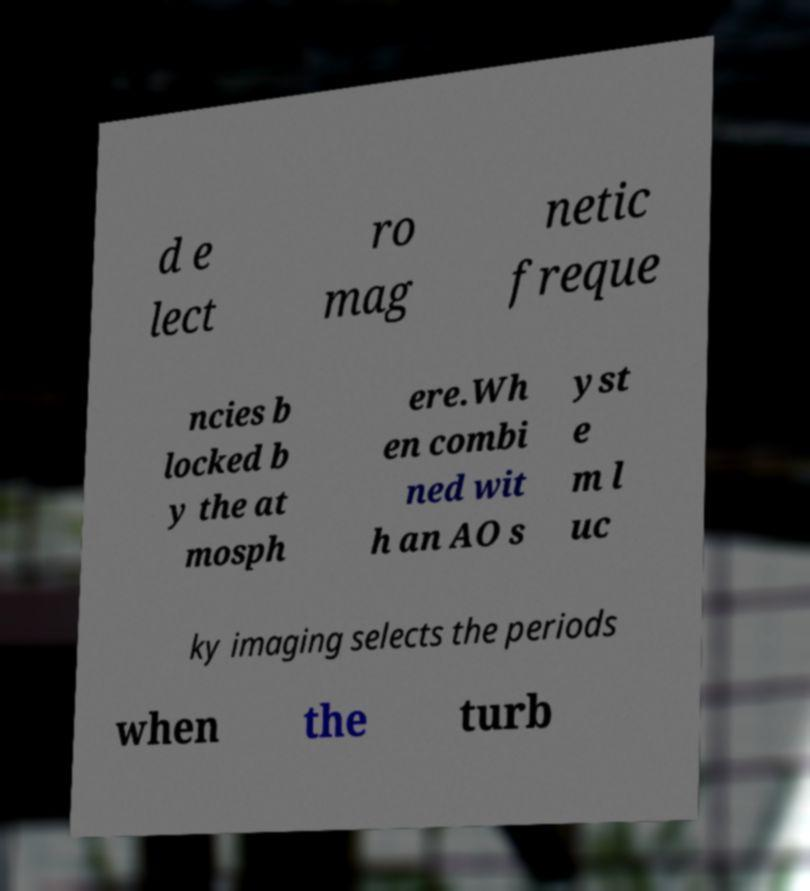Please identify and transcribe the text found in this image. d e lect ro mag netic freque ncies b locked b y the at mosph ere.Wh en combi ned wit h an AO s yst e m l uc ky imaging selects the periods when the turb 